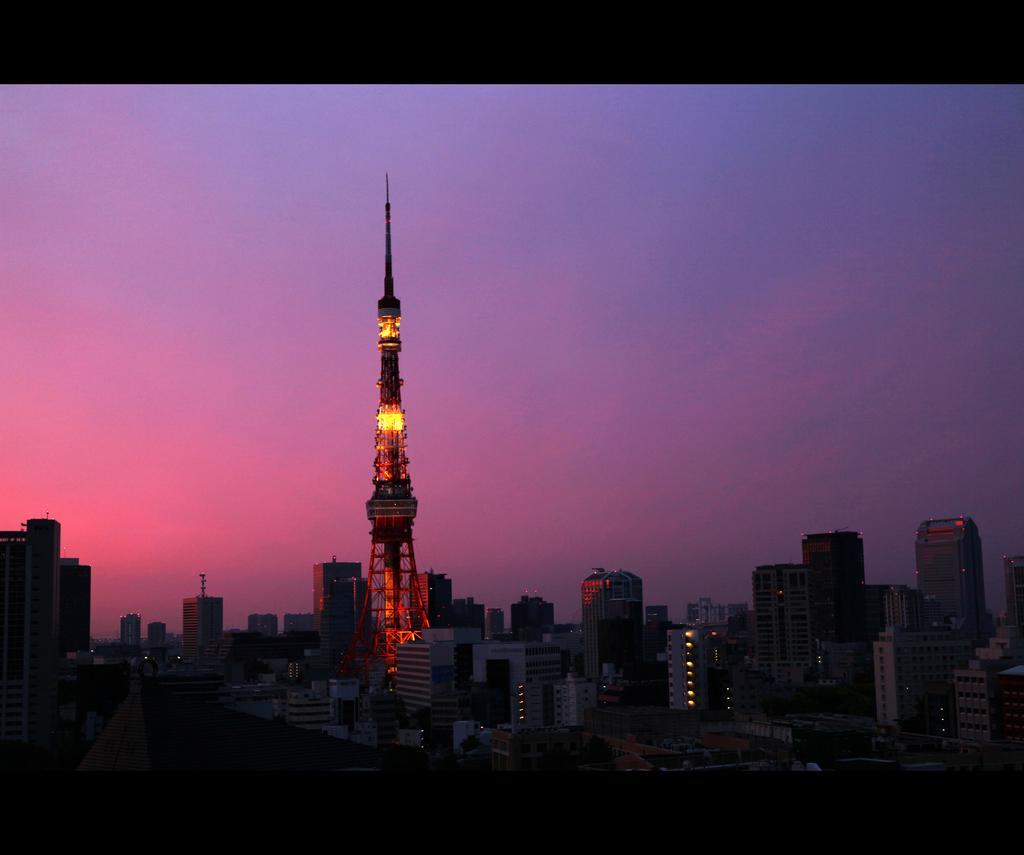What type of structures can be seen in the image? There are many buildings, including skyscrapers and a tower, in the image. What is visible at the top of the image? The sky is visible at the top of the image, and it contains clouds. What can be seen at the bottom of the image? Trees are visible at the bottom of the image. What is a feature of the landscape that connects the buildings and trees? There is a road in the image that connects the buildings and trees. Where is the river located in the image? There is no river present in the image. What type of amusement can be seen in the image? There is no amusement park or related activity depicted in the image. 